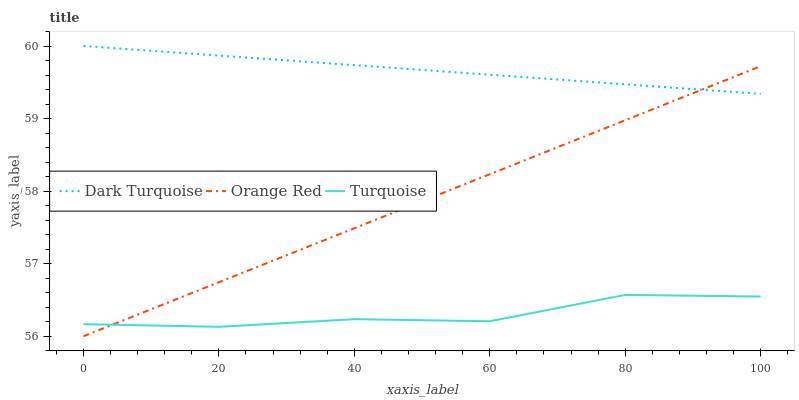Does Turquoise have the minimum area under the curve?
Answer yes or no. Yes. Does Dark Turquoise have the maximum area under the curve?
Answer yes or no. Yes. Does Orange Red have the minimum area under the curve?
Answer yes or no. No. Does Orange Red have the maximum area under the curve?
Answer yes or no. No. Is Orange Red the smoothest?
Answer yes or no. Yes. Is Turquoise the roughest?
Answer yes or no. Yes. Is Turquoise the smoothest?
Answer yes or no. No. Is Orange Red the roughest?
Answer yes or no. No. Does Orange Red have the lowest value?
Answer yes or no. Yes. Does Turquoise have the lowest value?
Answer yes or no. No. Does Dark Turquoise have the highest value?
Answer yes or no. Yes. Does Orange Red have the highest value?
Answer yes or no. No. Is Turquoise less than Dark Turquoise?
Answer yes or no. Yes. Is Dark Turquoise greater than Turquoise?
Answer yes or no. Yes. Does Orange Red intersect Dark Turquoise?
Answer yes or no. Yes. Is Orange Red less than Dark Turquoise?
Answer yes or no. No. Is Orange Red greater than Dark Turquoise?
Answer yes or no. No. Does Turquoise intersect Dark Turquoise?
Answer yes or no. No. 